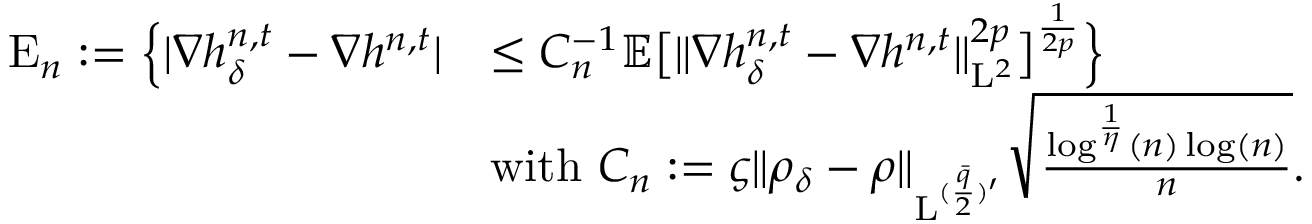<formula> <loc_0><loc_0><loc_500><loc_500>\begin{array} { r l } { E _ { n } \colon = \left \{ | \nabla h _ { \delta } ^ { n , t } - \nabla h ^ { n , t } | } & { \leq C _ { n } ^ { - 1 } \mathbb { E } \left [ \| \nabla h _ { \delta } ^ { n , t } - \nabla h ^ { n , t } \| _ { L ^ { 2 } } ^ { 2 p } \right ] ^ { \frac { 1 } { 2 p } } \right \} } \\ & { w i t h C _ { n } \colon = \varsigma \| \rho _ { \delta } - \rho \| _ { L ^ { ( \frac { \bar { q } } { 2 } ) ^ { \prime } } } \sqrt { \frac { \log ^ { \frac { 1 } { \eta } } ( n ) \log ( n ) } { n } } . } \end{array}</formula> 